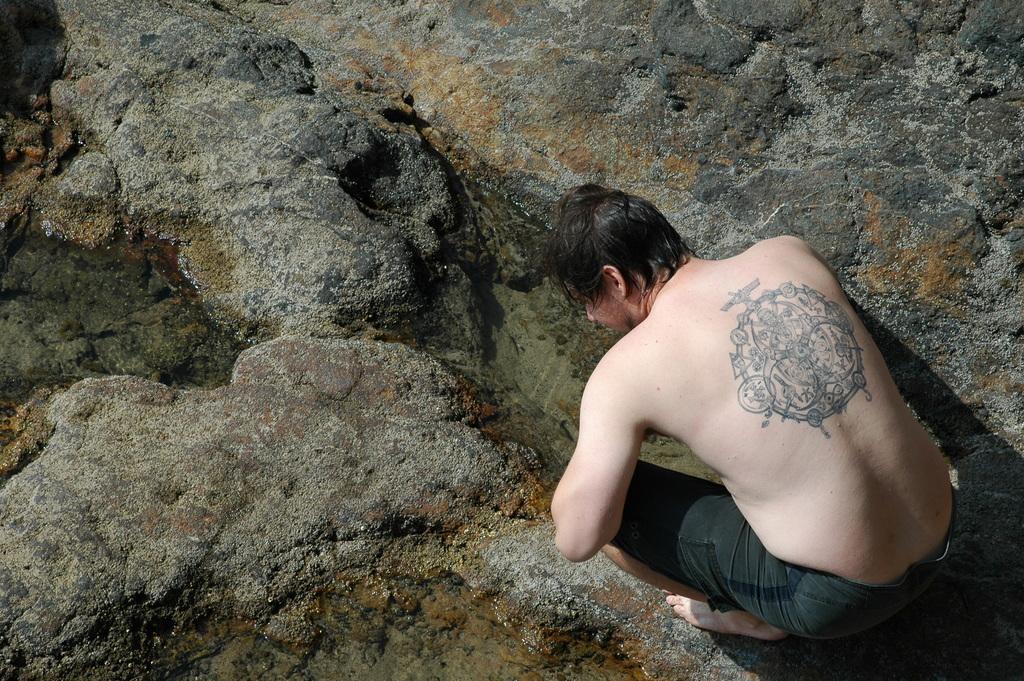Could you give a brief overview of what you see in this image? In this picture I can see a man in a squat position, there is water and there are rocks. 